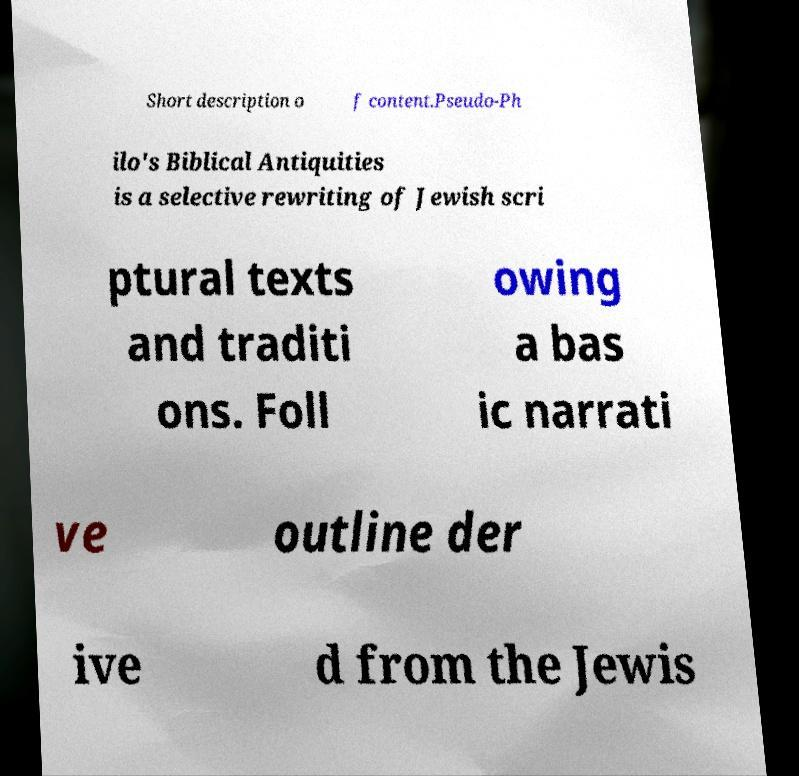Can you read and provide the text displayed in the image?This photo seems to have some interesting text. Can you extract and type it out for me? Short description o f content.Pseudo-Ph ilo's Biblical Antiquities is a selective rewriting of Jewish scri ptural texts and traditi ons. Foll owing a bas ic narrati ve outline der ive d from the Jewis 